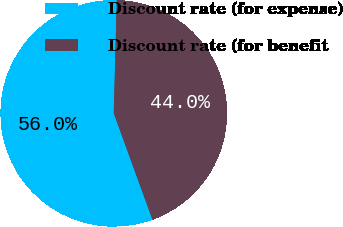Convert chart. <chart><loc_0><loc_0><loc_500><loc_500><pie_chart><fcel>Discount rate (for expense)<fcel>Discount rate (for benefit<nl><fcel>55.98%<fcel>44.02%<nl></chart> 